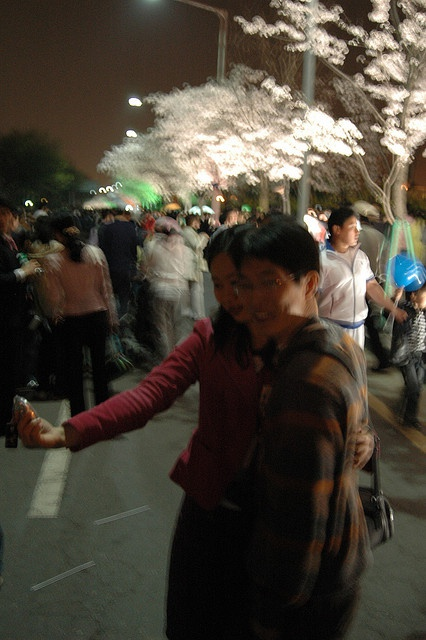Describe the objects in this image and their specific colors. I can see people in black, maroon, and gray tones, people in black, maroon, and gray tones, people in black, maroon, and gray tones, people in black, darkgray, white, and gray tones, and people in black, gray, and darkgray tones in this image. 